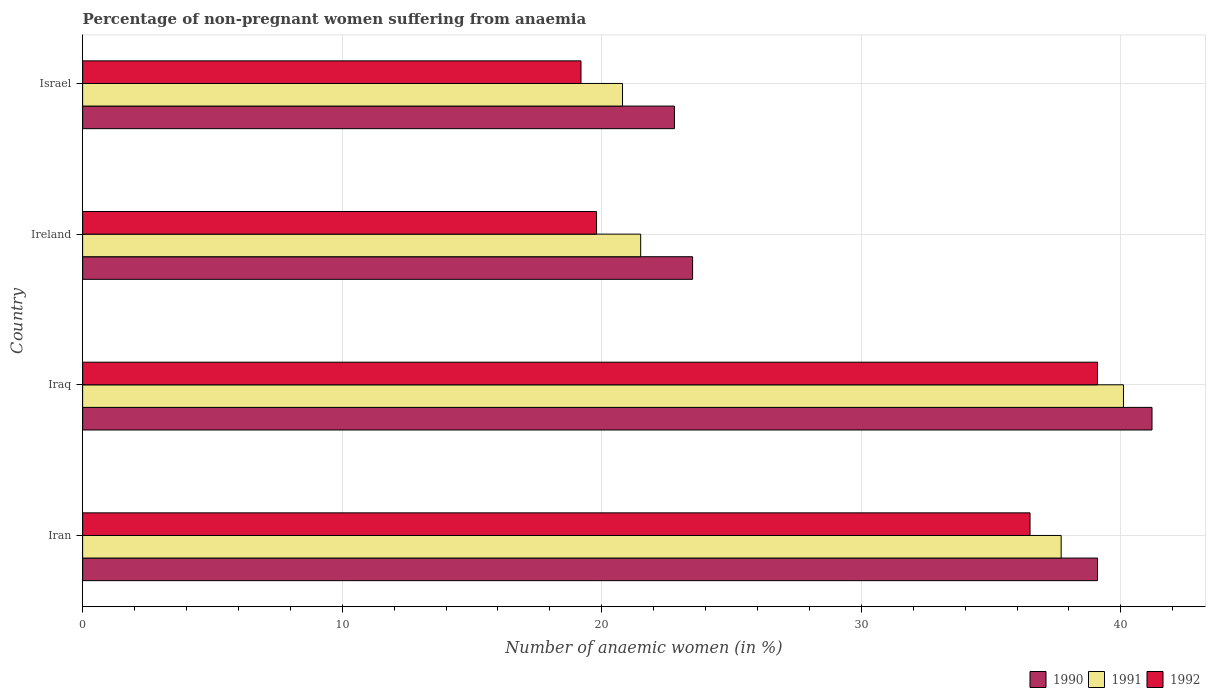How many different coloured bars are there?
Ensure brevity in your answer.  3. How many groups of bars are there?
Ensure brevity in your answer.  4. Are the number of bars on each tick of the Y-axis equal?
Ensure brevity in your answer.  Yes. What is the label of the 3rd group of bars from the top?
Provide a succinct answer. Iraq. In how many cases, is the number of bars for a given country not equal to the number of legend labels?
Ensure brevity in your answer.  0. What is the percentage of non-pregnant women suffering from anaemia in 1992 in Iran?
Provide a succinct answer. 36.5. Across all countries, what is the maximum percentage of non-pregnant women suffering from anaemia in 1991?
Provide a succinct answer. 40.1. In which country was the percentage of non-pregnant women suffering from anaemia in 1991 maximum?
Keep it short and to the point. Iraq. In which country was the percentage of non-pregnant women suffering from anaemia in 1992 minimum?
Give a very brief answer. Israel. What is the total percentage of non-pregnant women suffering from anaemia in 1990 in the graph?
Your answer should be compact. 126.6. What is the difference between the percentage of non-pregnant women suffering from anaemia in 1990 in Iran and that in Ireland?
Ensure brevity in your answer.  15.6. What is the difference between the percentage of non-pregnant women suffering from anaemia in 1991 in Israel and the percentage of non-pregnant women suffering from anaemia in 1992 in Iran?
Ensure brevity in your answer.  -15.7. What is the average percentage of non-pregnant women suffering from anaemia in 1992 per country?
Your response must be concise. 28.65. What is the difference between the percentage of non-pregnant women suffering from anaemia in 1992 and percentage of non-pregnant women suffering from anaemia in 1990 in Israel?
Your answer should be very brief. -3.6. What is the ratio of the percentage of non-pregnant women suffering from anaemia in 1991 in Iran to that in Ireland?
Give a very brief answer. 1.75. Is the difference between the percentage of non-pregnant women suffering from anaemia in 1992 in Iraq and Ireland greater than the difference between the percentage of non-pregnant women suffering from anaemia in 1990 in Iraq and Ireland?
Provide a short and direct response. Yes. What is the difference between the highest and the second highest percentage of non-pregnant women suffering from anaemia in 1991?
Keep it short and to the point. 2.4. What is the difference between the highest and the lowest percentage of non-pregnant women suffering from anaemia in 1990?
Ensure brevity in your answer.  18.4. In how many countries, is the percentage of non-pregnant women suffering from anaemia in 1990 greater than the average percentage of non-pregnant women suffering from anaemia in 1990 taken over all countries?
Ensure brevity in your answer.  2. Is the sum of the percentage of non-pregnant women suffering from anaemia in 1990 in Iran and Iraq greater than the maximum percentage of non-pregnant women suffering from anaemia in 1991 across all countries?
Make the answer very short. Yes. What does the 2nd bar from the top in Iran represents?
Your answer should be very brief. 1991. What does the 2nd bar from the bottom in Ireland represents?
Your answer should be very brief. 1991. Is it the case that in every country, the sum of the percentage of non-pregnant women suffering from anaemia in 1991 and percentage of non-pregnant women suffering from anaemia in 1992 is greater than the percentage of non-pregnant women suffering from anaemia in 1990?
Provide a succinct answer. Yes. Are all the bars in the graph horizontal?
Give a very brief answer. Yes. How many countries are there in the graph?
Offer a very short reply. 4. What is the difference between two consecutive major ticks on the X-axis?
Give a very brief answer. 10. Does the graph contain grids?
Provide a short and direct response. Yes. Where does the legend appear in the graph?
Provide a succinct answer. Bottom right. How many legend labels are there?
Your response must be concise. 3. What is the title of the graph?
Your answer should be compact. Percentage of non-pregnant women suffering from anaemia. What is the label or title of the X-axis?
Offer a terse response. Number of anaemic women (in %). What is the label or title of the Y-axis?
Your answer should be compact. Country. What is the Number of anaemic women (in %) of 1990 in Iran?
Your answer should be very brief. 39.1. What is the Number of anaemic women (in %) of 1991 in Iran?
Your answer should be very brief. 37.7. What is the Number of anaemic women (in %) in 1992 in Iran?
Provide a succinct answer. 36.5. What is the Number of anaemic women (in %) in 1990 in Iraq?
Keep it short and to the point. 41.2. What is the Number of anaemic women (in %) in 1991 in Iraq?
Provide a short and direct response. 40.1. What is the Number of anaemic women (in %) of 1992 in Iraq?
Offer a terse response. 39.1. What is the Number of anaemic women (in %) in 1991 in Ireland?
Make the answer very short. 21.5. What is the Number of anaemic women (in %) of 1992 in Ireland?
Provide a short and direct response. 19.8. What is the Number of anaemic women (in %) of 1990 in Israel?
Provide a short and direct response. 22.8. What is the Number of anaemic women (in %) of 1991 in Israel?
Provide a short and direct response. 20.8. What is the Number of anaemic women (in %) in 1992 in Israel?
Your answer should be compact. 19.2. Across all countries, what is the maximum Number of anaemic women (in %) in 1990?
Provide a short and direct response. 41.2. Across all countries, what is the maximum Number of anaemic women (in %) of 1991?
Offer a terse response. 40.1. Across all countries, what is the maximum Number of anaemic women (in %) of 1992?
Provide a succinct answer. 39.1. Across all countries, what is the minimum Number of anaemic women (in %) of 1990?
Give a very brief answer. 22.8. Across all countries, what is the minimum Number of anaemic women (in %) in 1991?
Provide a short and direct response. 20.8. What is the total Number of anaemic women (in %) of 1990 in the graph?
Offer a very short reply. 126.6. What is the total Number of anaemic women (in %) in 1991 in the graph?
Your answer should be compact. 120.1. What is the total Number of anaemic women (in %) in 1992 in the graph?
Your answer should be very brief. 114.6. What is the difference between the Number of anaemic women (in %) in 1991 in Iran and that in Iraq?
Ensure brevity in your answer.  -2.4. What is the difference between the Number of anaemic women (in %) in 1992 in Iran and that in Iraq?
Your response must be concise. -2.6. What is the difference between the Number of anaemic women (in %) of 1991 in Iran and that in Ireland?
Keep it short and to the point. 16.2. What is the difference between the Number of anaemic women (in %) in 1990 in Iran and that in Israel?
Give a very brief answer. 16.3. What is the difference between the Number of anaemic women (in %) in 1992 in Iran and that in Israel?
Offer a very short reply. 17.3. What is the difference between the Number of anaemic women (in %) in 1991 in Iraq and that in Ireland?
Make the answer very short. 18.6. What is the difference between the Number of anaemic women (in %) in 1992 in Iraq and that in Ireland?
Provide a succinct answer. 19.3. What is the difference between the Number of anaemic women (in %) in 1991 in Iraq and that in Israel?
Your answer should be compact. 19.3. What is the difference between the Number of anaemic women (in %) of 1990 in Ireland and that in Israel?
Your response must be concise. 0.7. What is the difference between the Number of anaemic women (in %) of 1991 in Ireland and that in Israel?
Provide a short and direct response. 0.7. What is the difference between the Number of anaemic women (in %) in 1992 in Ireland and that in Israel?
Keep it short and to the point. 0.6. What is the difference between the Number of anaemic women (in %) of 1990 in Iran and the Number of anaemic women (in %) of 1991 in Iraq?
Offer a very short reply. -1. What is the difference between the Number of anaemic women (in %) of 1991 in Iran and the Number of anaemic women (in %) of 1992 in Iraq?
Ensure brevity in your answer.  -1.4. What is the difference between the Number of anaemic women (in %) of 1990 in Iran and the Number of anaemic women (in %) of 1991 in Ireland?
Make the answer very short. 17.6. What is the difference between the Number of anaemic women (in %) in 1990 in Iran and the Number of anaemic women (in %) in 1992 in Ireland?
Make the answer very short. 19.3. What is the difference between the Number of anaemic women (in %) in 1990 in Iran and the Number of anaemic women (in %) in 1992 in Israel?
Ensure brevity in your answer.  19.9. What is the difference between the Number of anaemic women (in %) of 1990 in Iraq and the Number of anaemic women (in %) of 1991 in Ireland?
Give a very brief answer. 19.7. What is the difference between the Number of anaemic women (in %) of 1990 in Iraq and the Number of anaemic women (in %) of 1992 in Ireland?
Offer a very short reply. 21.4. What is the difference between the Number of anaemic women (in %) in 1991 in Iraq and the Number of anaemic women (in %) in 1992 in Ireland?
Give a very brief answer. 20.3. What is the difference between the Number of anaemic women (in %) of 1990 in Iraq and the Number of anaemic women (in %) of 1991 in Israel?
Ensure brevity in your answer.  20.4. What is the difference between the Number of anaemic women (in %) of 1991 in Iraq and the Number of anaemic women (in %) of 1992 in Israel?
Keep it short and to the point. 20.9. What is the difference between the Number of anaemic women (in %) in 1990 in Ireland and the Number of anaemic women (in %) in 1992 in Israel?
Provide a short and direct response. 4.3. What is the average Number of anaemic women (in %) in 1990 per country?
Provide a short and direct response. 31.65. What is the average Number of anaemic women (in %) of 1991 per country?
Your response must be concise. 30.02. What is the average Number of anaemic women (in %) in 1992 per country?
Your answer should be compact. 28.65. What is the difference between the Number of anaemic women (in %) of 1990 and Number of anaemic women (in %) of 1992 in Iran?
Offer a terse response. 2.6. What is the difference between the Number of anaemic women (in %) of 1991 and Number of anaemic women (in %) of 1992 in Iran?
Make the answer very short. 1.2. What is the difference between the Number of anaemic women (in %) in 1990 and Number of anaemic women (in %) in 1992 in Ireland?
Offer a very short reply. 3.7. What is the difference between the Number of anaemic women (in %) in 1991 and Number of anaemic women (in %) in 1992 in Ireland?
Make the answer very short. 1.7. What is the difference between the Number of anaemic women (in %) in 1990 and Number of anaemic women (in %) in 1992 in Israel?
Offer a very short reply. 3.6. What is the difference between the Number of anaemic women (in %) in 1991 and Number of anaemic women (in %) in 1992 in Israel?
Provide a short and direct response. 1.6. What is the ratio of the Number of anaemic women (in %) of 1990 in Iran to that in Iraq?
Your answer should be very brief. 0.95. What is the ratio of the Number of anaemic women (in %) of 1991 in Iran to that in Iraq?
Offer a very short reply. 0.94. What is the ratio of the Number of anaemic women (in %) of 1992 in Iran to that in Iraq?
Give a very brief answer. 0.93. What is the ratio of the Number of anaemic women (in %) in 1990 in Iran to that in Ireland?
Your response must be concise. 1.66. What is the ratio of the Number of anaemic women (in %) of 1991 in Iran to that in Ireland?
Provide a succinct answer. 1.75. What is the ratio of the Number of anaemic women (in %) of 1992 in Iran to that in Ireland?
Provide a short and direct response. 1.84. What is the ratio of the Number of anaemic women (in %) in 1990 in Iran to that in Israel?
Make the answer very short. 1.71. What is the ratio of the Number of anaemic women (in %) in 1991 in Iran to that in Israel?
Your response must be concise. 1.81. What is the ratio of the Number of anaemic women (in %) of 1992 in Iran to that in Israel?
Offer a terse response. 1.9. What is the ratio of the Number of anaemic women (in %) of 1990 in Iraq to that in Ireland?
Provide a short and direct response. 1.75. What is the ratio of the Number of anaemic women (in %) of 1991 in Iraq to that in Ireland?
Offer a very short reply. 1.87. What is the ratio of the Number of anaemic women (in %) of 1992 in Iraq to that in Ireland?
Your response must be concise. 1.97. What is the ratio of the Number of anaemic women (in %) of 1990 in Iraq to that in Israel?
Provide a succinct answer. 1.81. What is the ratio of the Number of anaemic women (in %) of 1991 in Iraq to that in Israel?
Provide a short and direct response. 1.93. What is the ratio of the Number of anaemic women (in %) of 1992 in Iraq to that in Israel?
Your answer should be compact. 2.04. What is the ratio of the Number of anaemic women (in %) in 1990 in Ireland to that in Israel?
Keep it short and to the point. 1.03. What is the ratio of the Number of anaemic women (in %) of 1991 in Ireland to that in Israel?
Keep it short and to the point. 1.03. What is the ratio of the Number of anaemic women (in %) in 1992 in Ireland to that in Israel?
Your answer should be very brief. 1.03. What is the difference between the highest and the second highest Number of anaemic women (in %) in 1990?
Your response must be concise. 2.1. What is the difference between the highest and the second highest Number of anaemic women (in %) in 1991?
Make the answer very short. 2.4. What is the difference between the highest and the second highest Number of anaemic women (in %) of 1992?
Your answer should be compact. 2.6. What is the difference between the highest and the lowest Number of anaemic women (in %) of 1990?
Give a very brief answer. 18.4. What is the difference between the highest and the lowest Number of anaemic women (in %) of 1991?
Give a very brief answer. 19.3. 